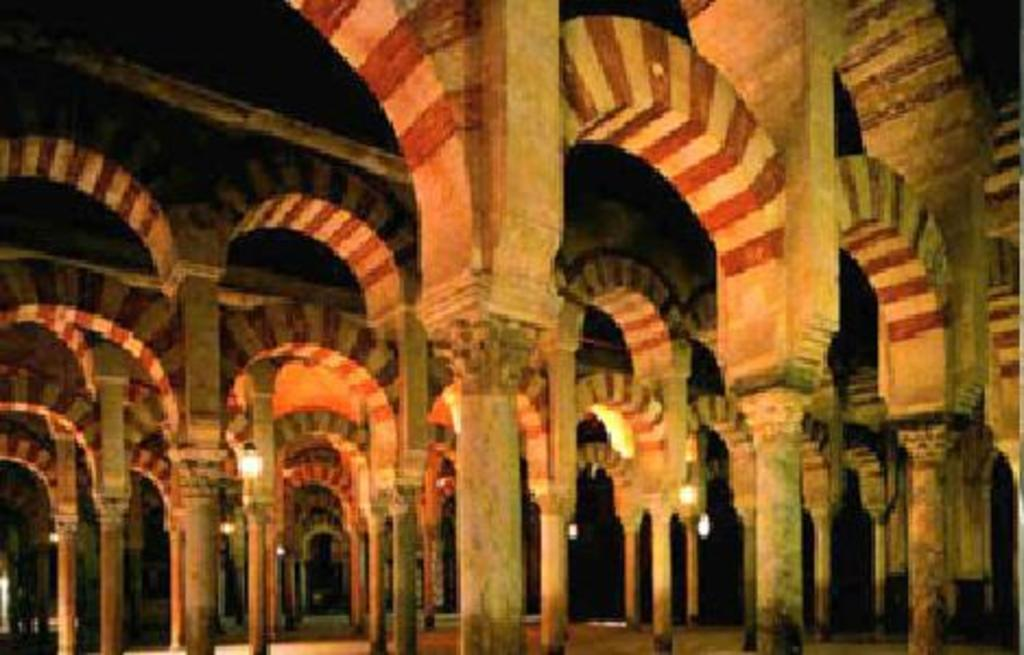What architectural elements can be seen in the image? There are pillars and an arch in the image. What type of lighting is present in the image? There are lights in the image. What part of a building is visible at the top of the image? The roof is visible at the top of the image. How many women are standing on the pillars in the image? There are no women present in the image. Are there any giants visible in the image? There are no giants present in the image. 